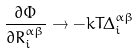Convert formula to latex. <formula><loc_0><loc_0><loc_500><loc_500>\frac { \partial \Phi } { \partial R ^ { \alpha \beta } _ { i } } \rightarrow - k T \Delta _ { i } ^ { \alpha \beta }</formula> 